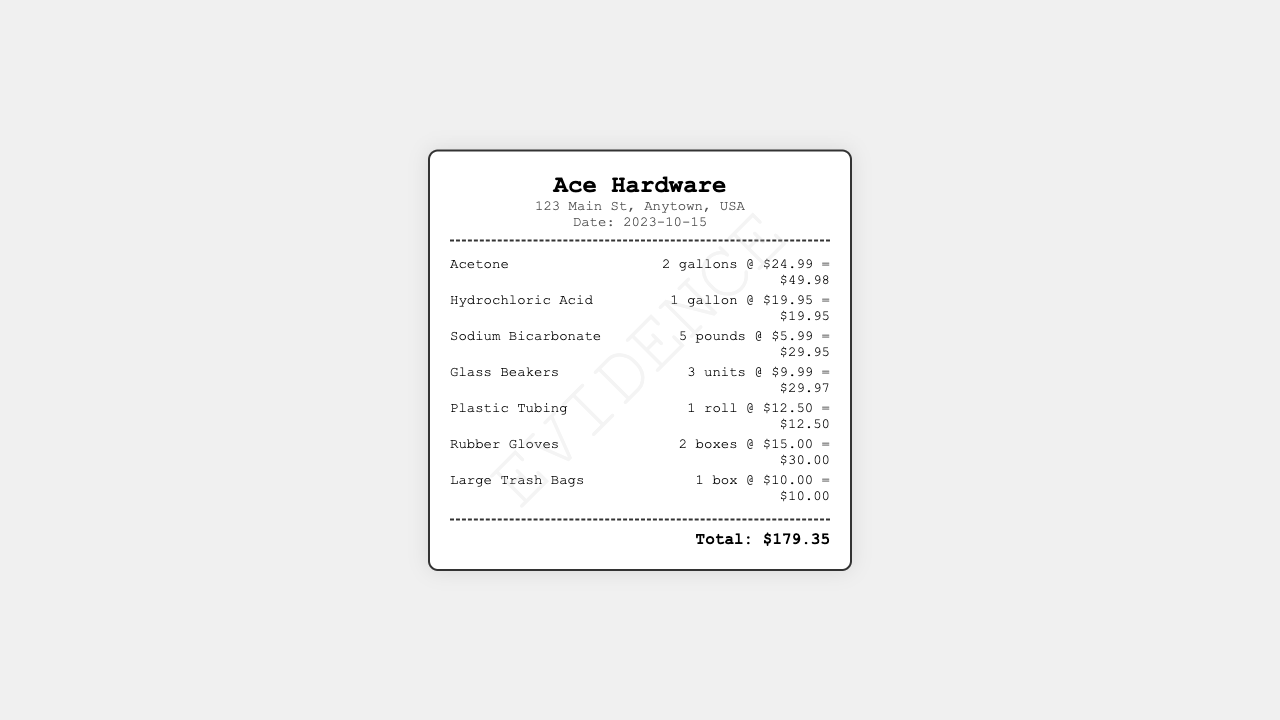What is the store name? The store name is displayed prominently at the top of the receipt.
Answer: Ace Hardware What date was the purchase made? The purchase date is listed under the store information section.
Answer: 2023-10-15 How many gallons of Acetone were purchased? The quantity of Acetone is indicated next to the item on the receipt.
Answer: 2 gallons What is the price of Hydrochloric Acid per gallon? The price per gallon is stated next to Hydrochloric Acid.
Answer: $19.95 What is the total amount spent? The total amount is shown at the bottom of the receipt.
Answer: $179.35 Which item has the highest quantity purchased? This question requires looking at the quantities of all items on the receipt.
Answer: Sodium Bicarbonate How many boxes of Rubber Gloves were bought? The quantity purchased for Rubber Gloves is indicated in the item details.
Answer: 2 boxes What is the total cost of Plastic Tubing? The total cost is provided in the item details for Plastic Tubing.
Answer: $12.50 What items are included in the receipt? This question looks for a list of items present on the receipt.
Answer: Acetone, Hydrochloric Acid, Sodium Bicarbonate, Glass Beakers, Plastic Tubing, Rubber Gloves, Large Trash Bags 